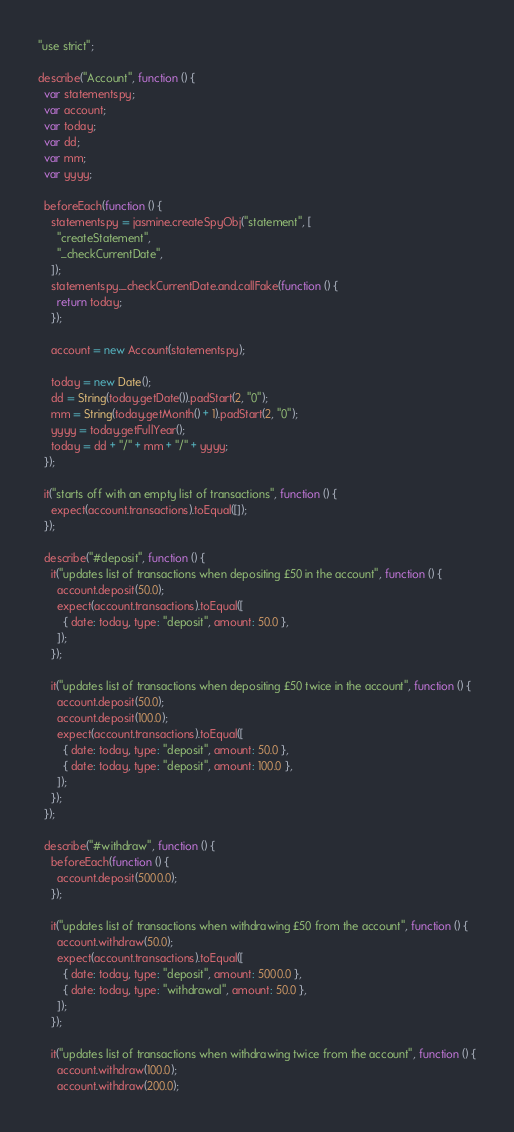Convert code to text. <code><loc_0><loc_0><loc_500><loc_500><_JavaScript_>"use strict";

describe("Account", function () {
  var statementspy;
  var account;
  var today;
  var dd;
  var mm;
  var yyyy;

  beforeEach(function () {
    statementspy = jasmine.createSpyObj("statement", [
      "createStatement",
      "_checkCurrentDate",
    ]);
    statementspy._checkCurrentDate.and.callFake(function () {
      return today;
    });

    account = new Account(statementspy);

    today = new Date();
    dd = String(today.getDate()).padStart(2, "0");
    mm = String(today.getMonth() + 1).padStart(2, "0");
    yyyy = today.getFullYear();
    today = dd + "/" + mm + "/" + yyyy;
  });

  it("starts off with an empty list of transactions", function () {
    expect(account.transactions).toEqual([]);
  });

  describe("#deposit", function () {
    it("updates list of transactions when depositing £50 in the account", function () {
      account.deposit(50.0);
      expect(account.transactions).toEqual([
        { date: today, type: "deposit", amount: 50.0 },
      ]);
    });

    it("updates list of transactions when depositing £50 twice in the account", function () {
      account.deposit(50.0);
      account.deposit(100.0);
      expect(account.transactions).toEqual([
        { date: today, type: "deposit", amount: 50.0 },
        { date: today, type: "deposit", amount: 100.0 },
      ]);
    });
  });

  describe("#withdraw", function () {
    beforeEach(function () {
      account.deposit(5000.0);
    });

    it("updates list of transactions when withdrawing £50 from the account", function () {
      account.withdraw(50.0);
      expect(account.transactions).toEqual([
        { date: today, type: "deposit", amount: 5000.0 },
        { date: today, type: "withdrawal", amount: 50.0 },
      ]);
    });

    it("updates list of transactions when withdrawing twice from the account", function () {
      account.withdraw(100.0);
      account.withdraw(200.0);</code> 